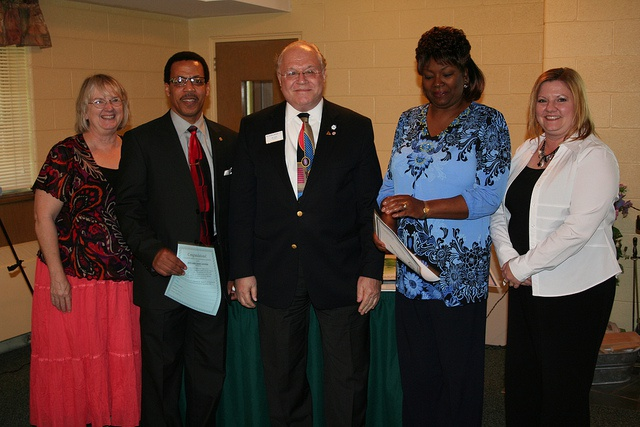Describe the objects in this image and their specific colors. I can see people in black, gray, and maroon tones, people in black, brown, and lightgray tones, people in black, darkgray, and brown tones, people in black, maroon, darkgray, and gray tones, and people in black, brown, and maroon tones in this image. 